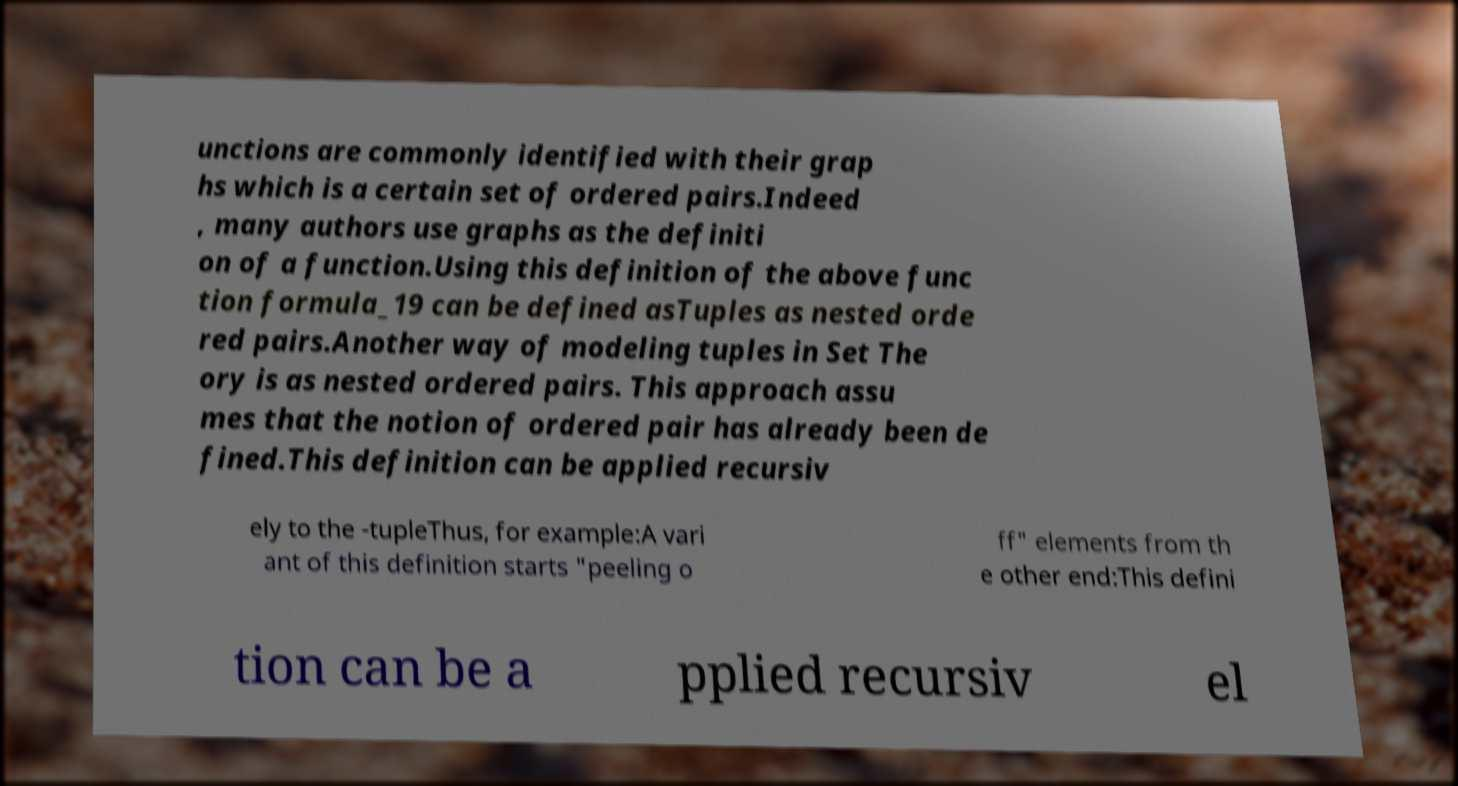What messages or text are displayed in this image? I need them in a readable, typed format. unctions are commonly identified with their grap hs which is a certain set of ordered pairs.Indeed , many authors use graphs as the definiti on of a function.Using this definition of the above func tion formula_19 can be defined asTuples as nested orde red pairs.Another way of modeling tuples in Set The ory is as nested ordered pairs. This approach assu mes that the notion of ordered pair has already been de fined.This definition can be applied recursiv ely to the -tupleThus, for example:A vari ant of this definition starts "peeling o ff" elements from th e other end:This defini tion can be a pplied recursiv el 